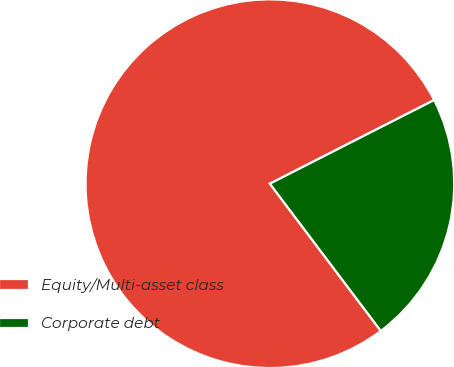Convert chart to OTSL. <chart><loc_0><loc_0><loc_500><loc_500><pie_chart><fcel>Equity/Multi-asset class<fcel>Corporate debt<nl><fcel>77.78%<fcel>22.22%<nl></chart> 